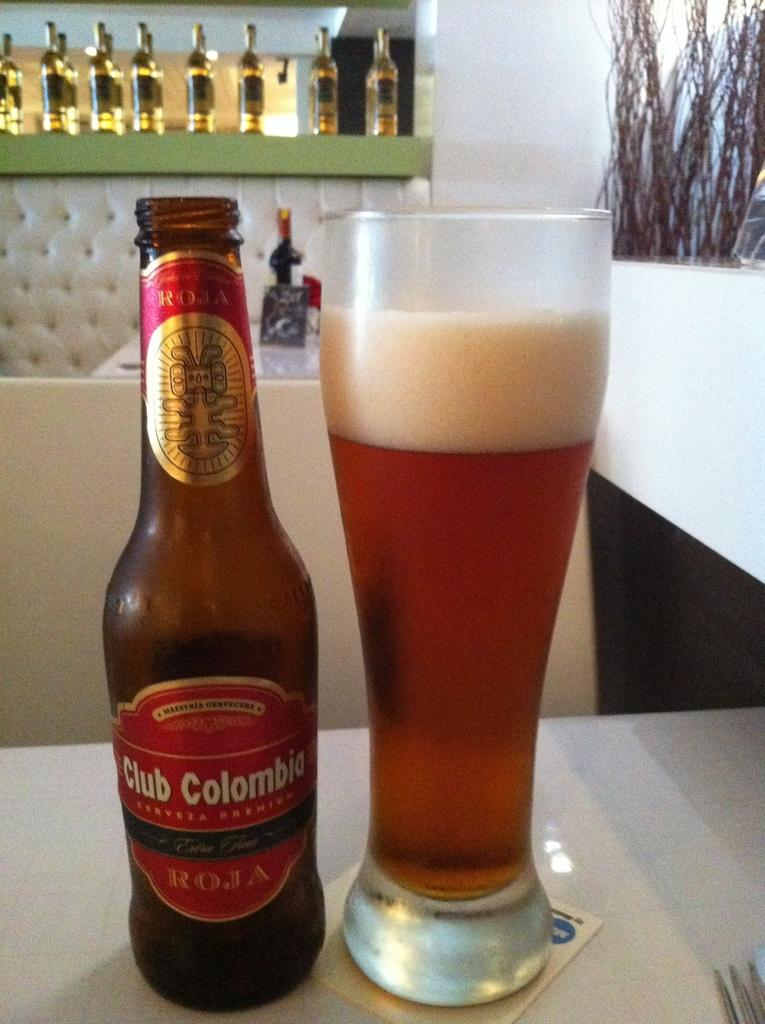Provide a one-sentence caption for the provided image. A brown bottle of Club Columbia beer sitting next to a glass of beer on a table in a restaurant. 